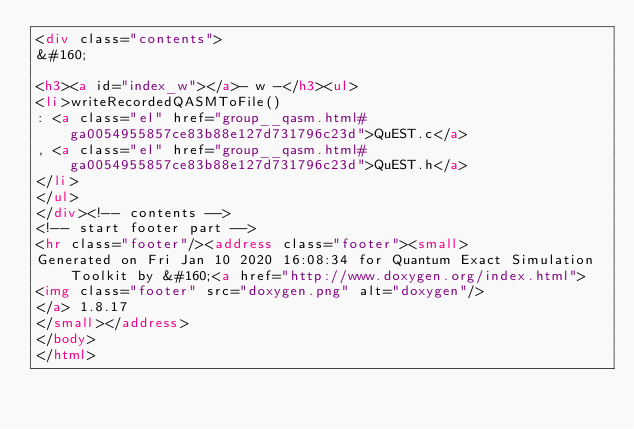<code> <loc_0><loc_0><loc_500><loc_500><_HTML_><div class="contents">
&#160;

<h3><a id="index_w"></a>- w -</h3><ul>
<li>writeRecordedQASMToFile()
: <a class="el" href="group__qasm.html#ga0054955857ce83b88e127d731796c23d">QuEST.c</a>
, <a class="el" href="group__qasm.html#ga0054955857ce83b88e127d731796c23d">QuEST.h</a>
</li>
</ul>
</div><!-- contents -->
<!-- start footer part -->
<hr class="footer"/><address class="footer"><small>
Generated on Fri Jan 10 2020 16:08:34 for Quantum Exact Simulation Toolkit by &#160;<a href="http://www.doxygen.org/index.html">
<img class="footer" src="doxygen.png" alt="doxygen"/>
</a> 1.8.17
</small></address>
</body>
</html>
</code> 